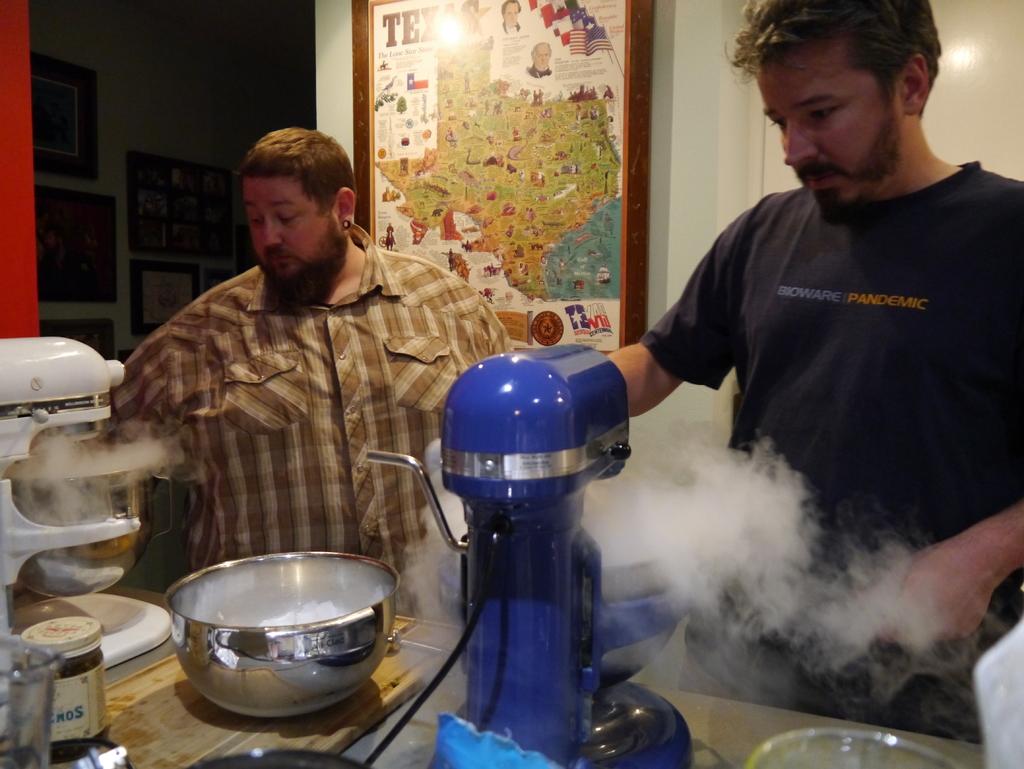What does the man's shirt say?
Provide a succinct answer. Bioware pandemic. 